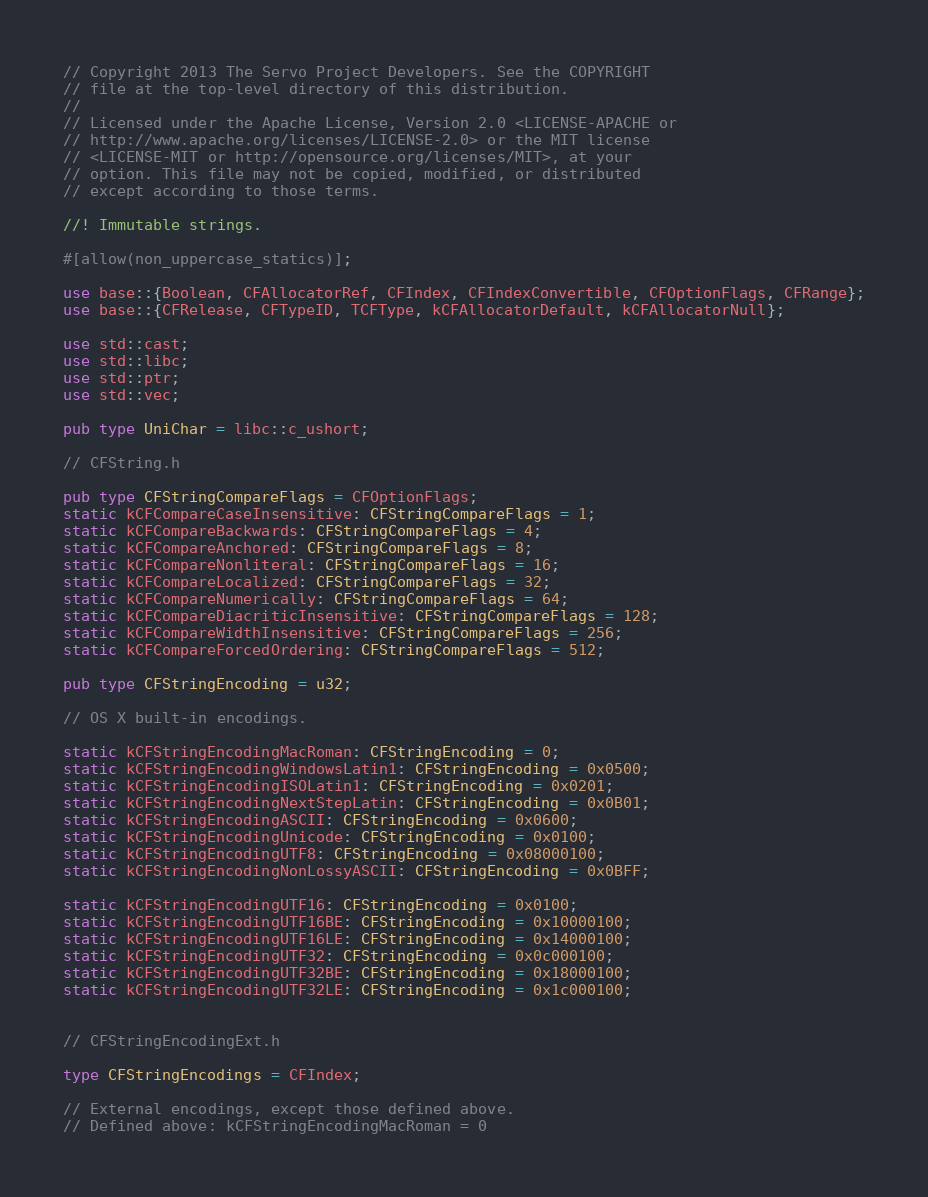<code> <loc_0><loc_0><loc_500><loc_500><_Rust_>// Copyright 2013 The Servo Project Developers. See the COPYRIGHT
// file at the top-level directory of this distribution.
//
// Licensed under the Apache License, Version 2.0 <LICENSE-APACHE or
// http://www.apache.org/licenses/LICENSE-2.0> or the MIT license
// <LICENSE-MIT or http://opensource.org/licenses/MIT>, at your
// option. This file may not be copied, modified, or distributed
// except according to those terms.

//! Immutable strings.

#[allow(non_uppercase_statics)];

use base::{Boolean, CFAllocatorRef, CFIndex, CFIndexConvertible, CFOptionFlags, CFRange};
use base::{CFRelease, CFTypeID, TCFType, kCFAllocatorDefault, kCFAllocatorNull};

use std::cast;
use std::libc;
use std::ptr;
use std::vec;

pub type UniChar = libc::c_ushort;

// CFString.h

pub type CFStringCompareFlags = CFOptionFlags;
static kCFCompareCaseInsensitive: CFStringCompareFlags = 1;
static kCFCompareBackwards: CFStringCompareFlags = 4;
static kCFCompareAnchored: CFStringCompareFlags = 8;
static kCFCompareNonliteral: CFStringCompareFlags = 16;
static kCFCompareLocalized: CFStringCompareFlags = 32;
static kCFCompareNumerically: CFStringCompareFlags = 64;
static kCFCompareDiacriticInsensitive: CFStringCompareFlags = 128;
static kCFCompareWidthInsensitive: CFStringCompareFlags = 256;
static kCFCompareForcedOrdering: CFStringCompareFlags = 512;

pub type CFStringEncoding = u32;

// OS X built-in encodings.

static kCFStringEncodingMacRoman: CFStringEncoding = 0;
static kCFStringEncodingWindowsLatin1: CFStringEncoding = 0x0500;
static kCFStringEncodingISOLatin1: CFStringEncoding = 0x0201;
static kCFStringEncodingNextStepLatin: CFStringEncoding = 0x0B01;
static kCFStringEncodingASCII: CFStringEncoding = 0x0600;
static kCFStringEncodingUnicode: CFStringEncoding = 0x0100;
static kCFStringEncodingUTF8: CFStringEncoding = 0x08000100;
static kCFStringEncodingNonLossyASCII: CFStringEncoding = 0x0BFF;

static kCFStringEncodingUTF16: CFStringEncoding = 0x0100;
static kCFStringEncodingUTF16BE: CFStringEncoding = 0x10000100;
static kCFStringEncodingUTF16LE: CFStringEncoding = 0x14000100;
static kCFStringEncodingUTF32: CFStringEncoding = 0x0c000100;
static kCFStringEncodingUTF32BE: CFStringEncoding = 0x18000100;
static kCFStringEncodingUTF32LE: CFStringEncoding = 0x1c000100;


// CFStringEncodingExt.h

type CFStringEncodings = CFIndex;

// External encodings, except those defined above.
// Defined above: kCFStringEncodingMacRoman = 0</code> 